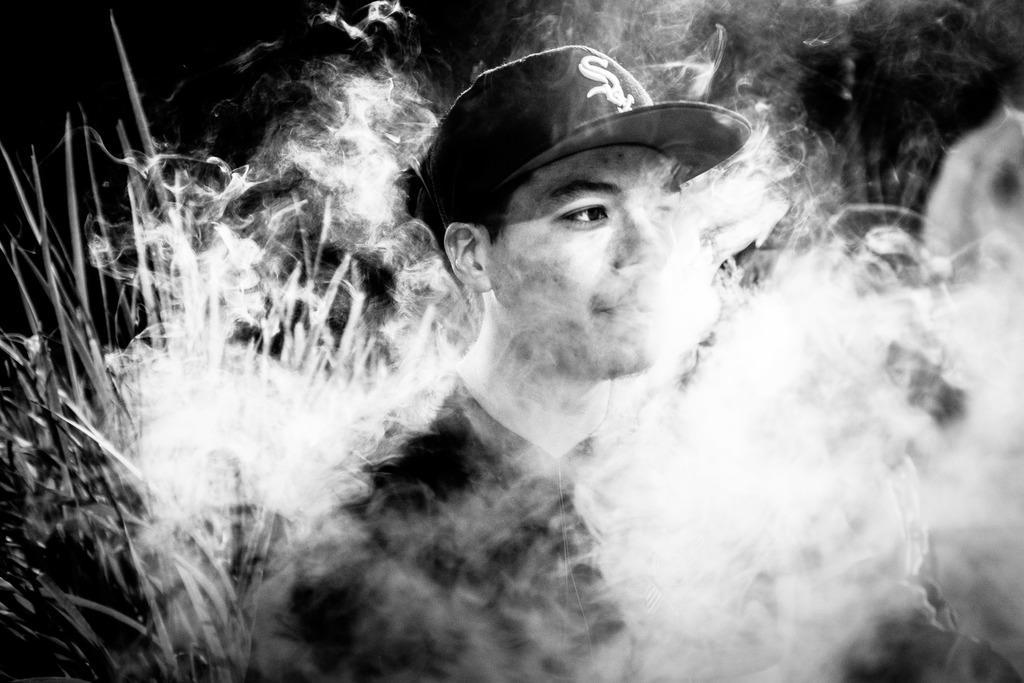In one or two sentences, can you explain what this image depicts? In this picture there is a man who is wearing cap and t-shirt. Beside him I can see the smoke. On the left I can see the plants. In the top left corner I can see the darkness. 